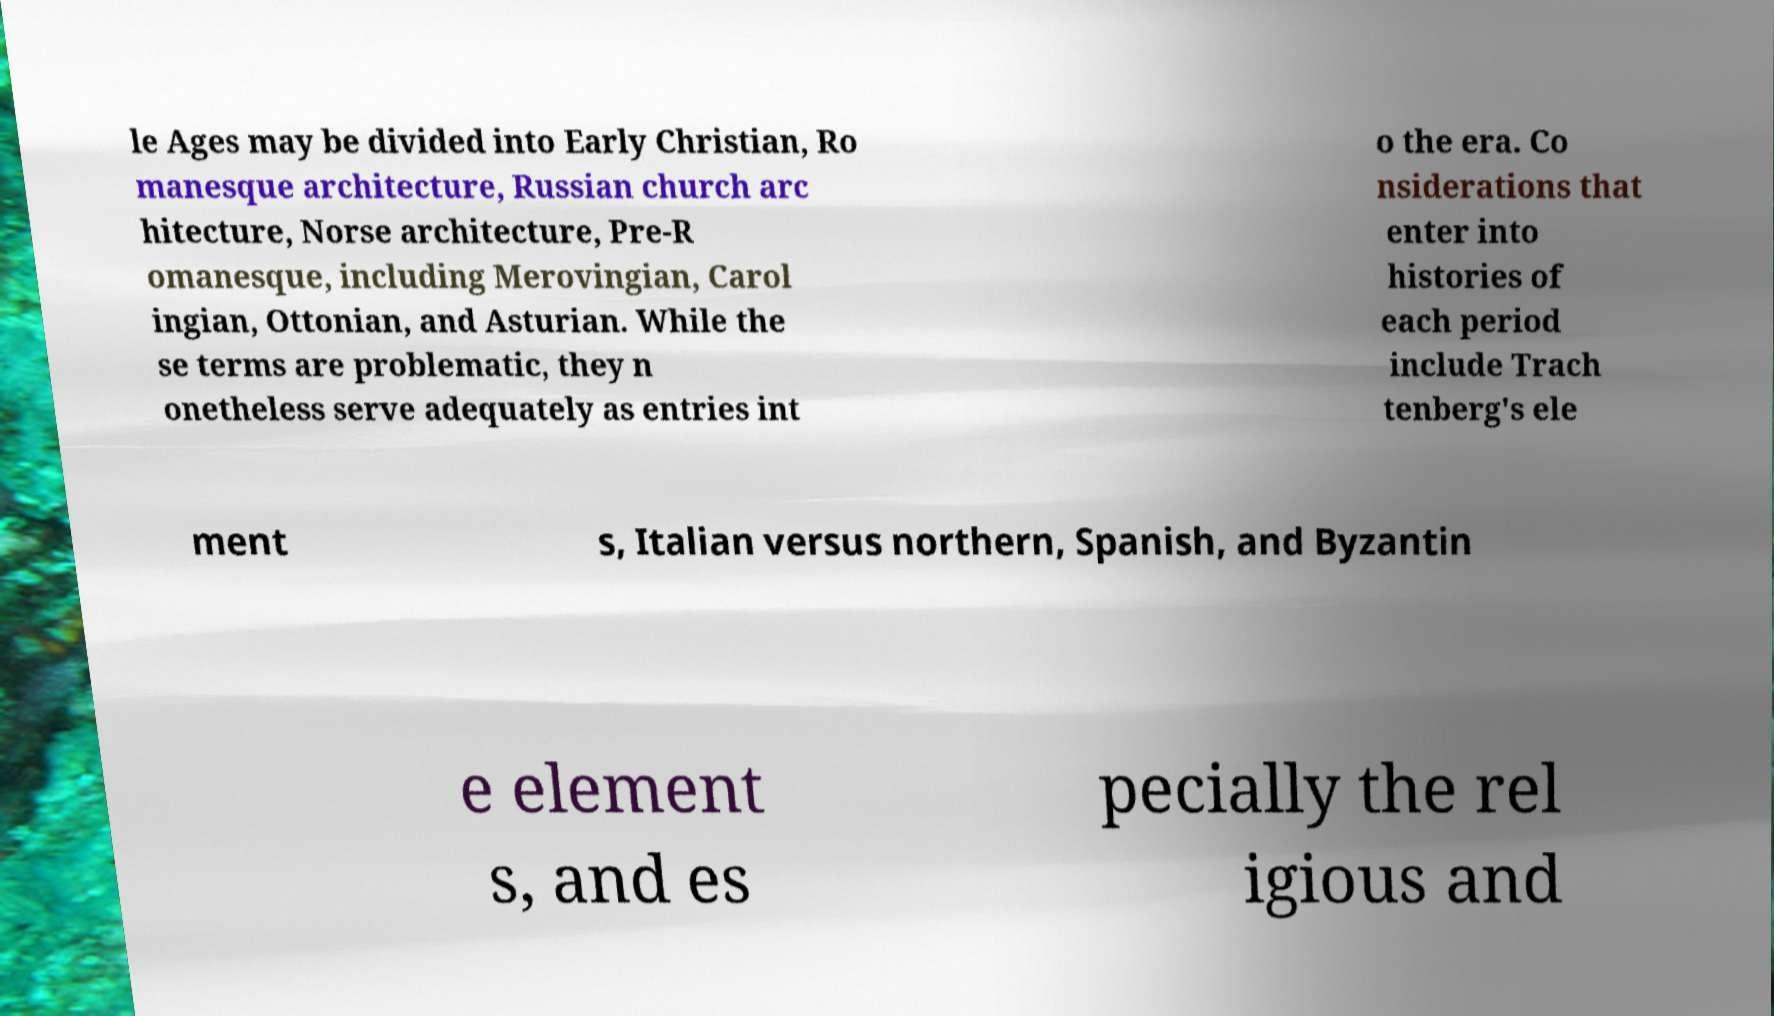I need the written content from this picture converted into text. Can you do that? le Ages may be divided into Early Christian, Ro manesque architecture, Russian church arc hitecture, Norse architecture, Pre-R omanesque, including Merovingian, Carol ingian, Ottonian, and Asturian. While the se terms are problematic, they n onetheless serve adequately as entries int o the era. Co nsiderations that enter into histories of each period include Trach tenberg's ele ment s, Italian versus northern, Spanish, and Byzantin e element s, and es pecially the rel igious and 